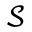Convert formula to latex. <formula><loc_0><loc_0><loc_500><loc_500>\mathcal { S }</formula> 